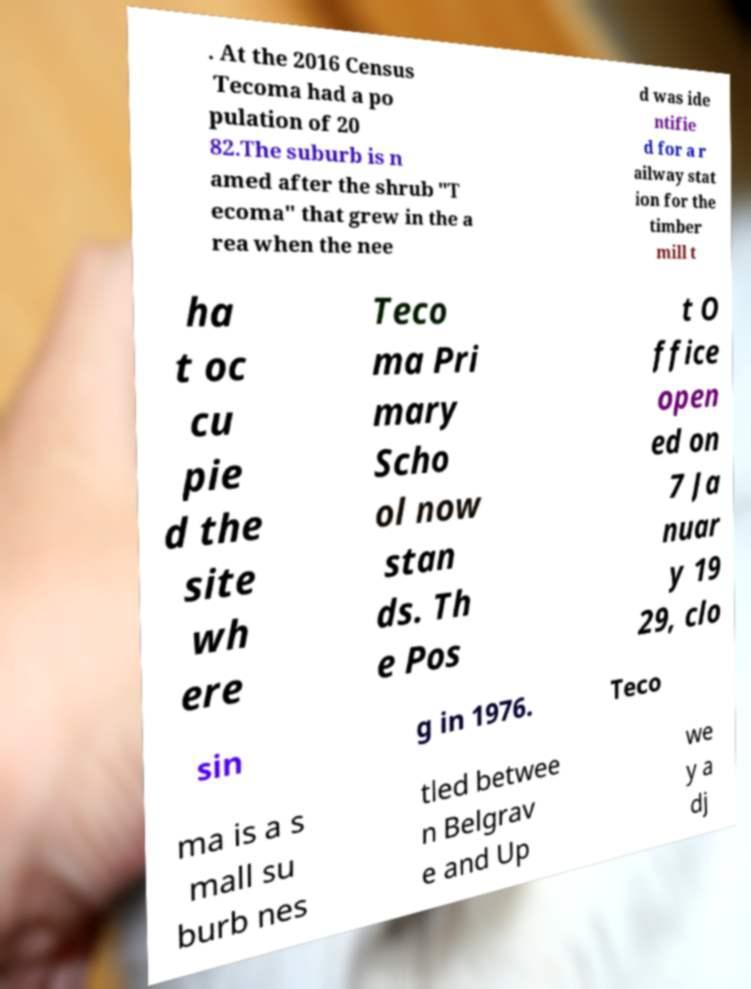Please identify and transcribe the text found in this image. . At the 2016 Census Tecoma had a po pulation of 20 82.The suburb is n amed after the shrub "T ecoma" that grew in the a rea when the nee d was ide ntifie d for a r ailway stat ion for the timber mill t ha t oc cu pie d the site wh ere Teco ma Pri mary Scho ol now stan ds. Th e Pos t O ffice open ed on 7 Ja nuar y 19 29, clo sin g in 1976. Teco ma is a s mall su burb nes tled betwee n Belgrav e and Up we y a dj 